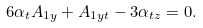Convert formula to latex. <formula><loc_0><loc_0><loc_500><loc_500>6 \alpha _ { t } A _ { 1 y } + A _ { 1 y t } - 3 \alpha _ { t z } = 0 .</formula> 